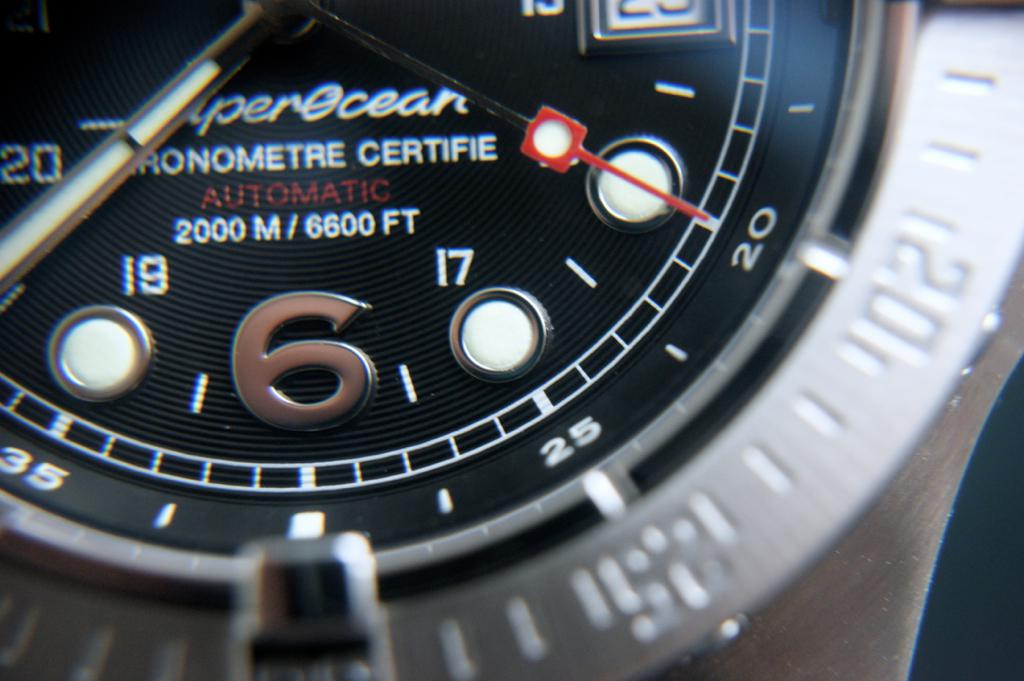Provide a one-sentence caption for the provided image. This image captures a close-up view of a luxury dive watch, the Superocean by Breitling, featuring a distinctive black dial with a red second hand, marked as 'AUTOMATIC 2000 M / 6600 FT' to indicate its water resistance. 